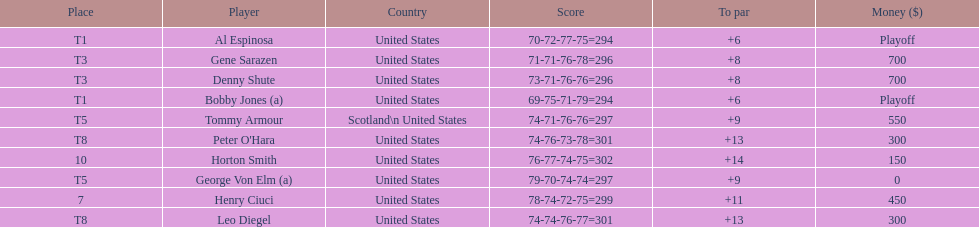Who was the last player in the top 10? Horton Smith. 